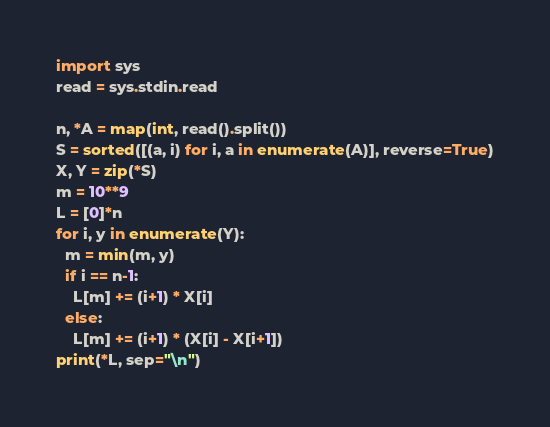Convert code to text. <code><loc_0><loc_0><loc_500><loc_500><_Python_>import sys
read = sys.stdin.read

n, *A = map(int, read().split())
S = sorted([(a, i) for i, a in enumerate(A)], reverse=True)
X, Y = zip(*S)
m = 10**9
L = [0]*n
for i, y in enumerate(Y):
  m = min(m, y)
  if i == n-1:
    L[m] += (i+1) * X[i]
  else:
    L[m] += (i+1) * (X[i] - X[i+1])
print(*L, sep="\n")</code> 